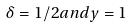Convert formula to latex. <formula><loc_0><loc_0><loc_500><loc_500>\delta = 1 / 2 a n d y = 1</formula> 